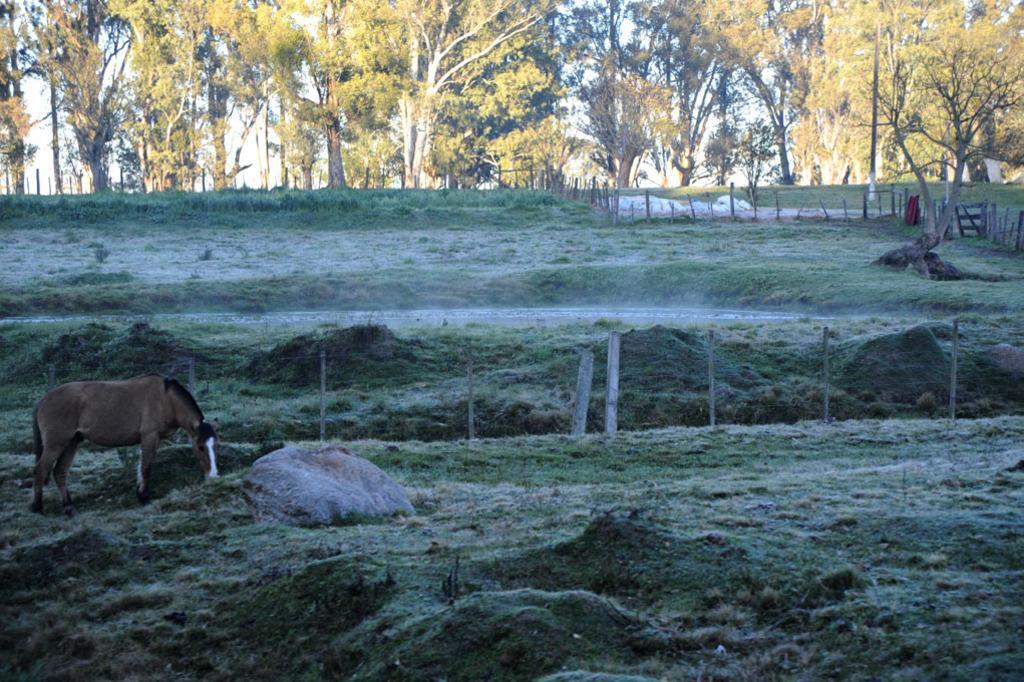Can you describe this image briefly? In this image I can see an open grass ground and on it I can see a horse is standing. In the background I can see number of trees and number of poles. 